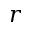<formula> <loc_0><loc_0><loc_500><loc_500>r</formula> 